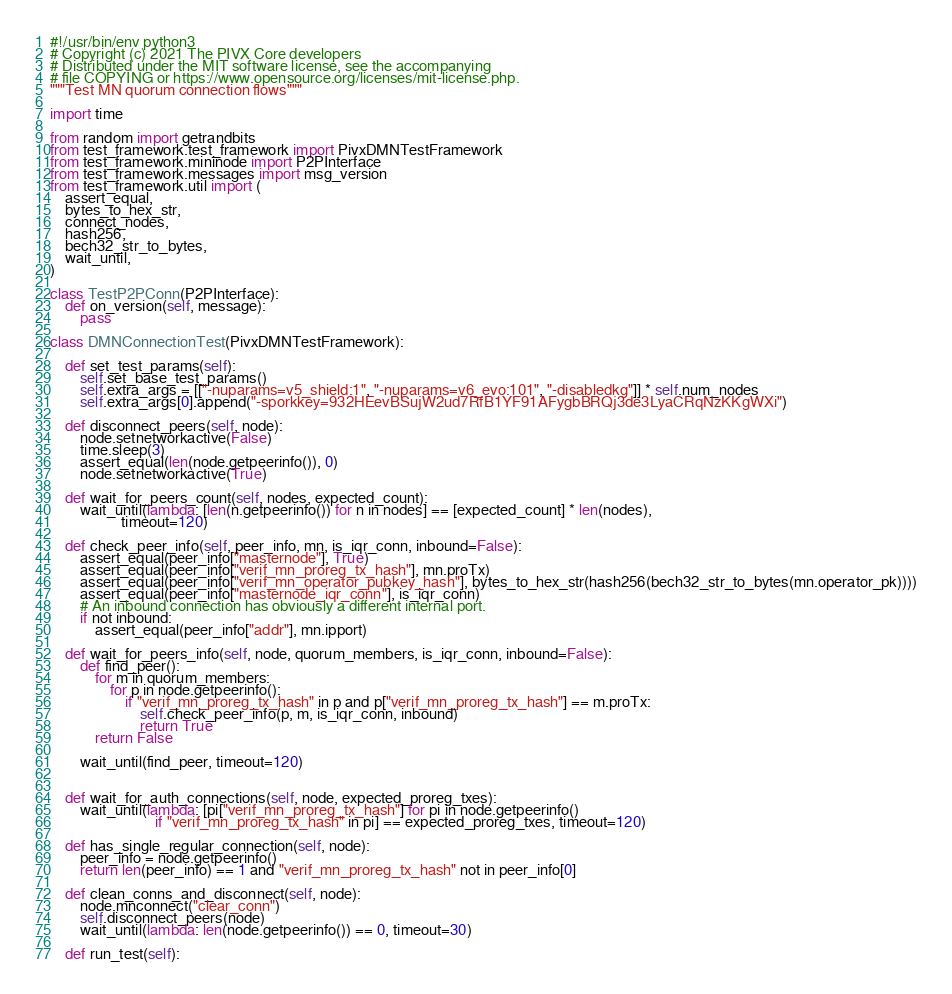Convert code to text. <code><loc_0><loc_0><loc_500><loc_500><_Python_>#!/usr/bin/env python3
# Copyright (c) 2021 The PIVX Core developers
# Distributed under the MIT software license, see the accompanying
# file COPYING or https://www.opensource.org/licenses/mit-license.php.
"""Test MN quorum connection flows"""

import time

from random import getrandbits
from test_framework.test_framework import PivxDMNTestFramework
from test_framework.mininode import P2PInterface
from test_framework.messages import msg_version
from test_framework.util import (
    assert_equal,
    bytes_to_hex_str,
    connect_nodes,
    hash256,
    bech32_str_to_bytes,
    wait_until,
)

class TestP2PConn(P2PInterface):
    def on_version(self, message):
        pass

class DMNConnectionTest(PivxDMNTestFramework):

    def set_test_params(self):
        self.set_base_test_params()
        self.extra_args = [["-nuparams=v5_shield:1", "-nuparams=v6_evo:101", "-disabledkg"]] * self.num_nodes
        self.extra_args[0].append("-sporkkey=932HEevBSujW2ud7RfB1YF91AFygbBRQj3de3LyaCRqNzKKgWXi")

    def disconnect_peers(self, node):
        node.setnetworkactive(False)
        time.sleep(3)
        assert_equal(len(node.getpeerinfo()), 0)
        node.setnetworkactive(True)

    def wait_for_peers_count(self, nodes, expected_count):
        wait_until(lambda: [len(n.getpeerinfo()) for n in nodes] == [expected_count] * len(nodes),
                   timeout=120)

    def check_peer_info(self, peer_info, mn, is_iqr_conn, inbound=False):
        assert_equal(peer_info["masternode"], True)
        assert_equal(peer_info["verif_mn_proreg_tx_hash"], mn.proTx)
        assert_equal(peer_info["verif_mn_operator_pubkey_hash"], bytes_to_hex_str(hash256(bech32_str_to_bytes(mn.operator_pk))))
        assert_equal(peer_info["masternode_iqr_conn"], is_iqr_conn)
        # An inbound connection has obviously a different internal port.
        if not inbound:
            assert_equal(peer_info["addr"], mn.ipport)

    def wait_for_peers_info(self, node, quorum_members, is_iqr_conn, inbound=False):
        def find_peer():
            for m in quorum_members:
                for p in node.getpeerinfo():
                    if "verif_mn_proreg_tx_hash" in p and p["verif_mn_proreg_tx_hash"] == m.proTx:
                        self.check_peer_info(p, m, is_iqr_conn, inbound)
                        return True
            return False

        wait_until(find_peer, timeout=120)


    def wait_for_auth_connections(self, node, expected_proreg_txes):
        wait_until(lambda: [pi["verif_mn_proreg_tx_hash"] for pi in node.getpeerinfo()
                            if "verif_mn_proreg_tx_hash" in pi] == expected_proreg_txes, timeout=120)

    def has_single_regular_connection(self, node):
        peer_info = node.getpeerinfo()
        return len(peer_info) == 1 and "verif_mn_proreg_tx_hash" not in peer_info[0]

    def clean_conns_and_disconnect(self, node):
        node.mnconnect("clear_conn")
        self.disconnect_peers(node)
        wait_until(lambda: len(node.getpeerinfo()) == 0, timeout=30)

    def run_test(self):</code> 